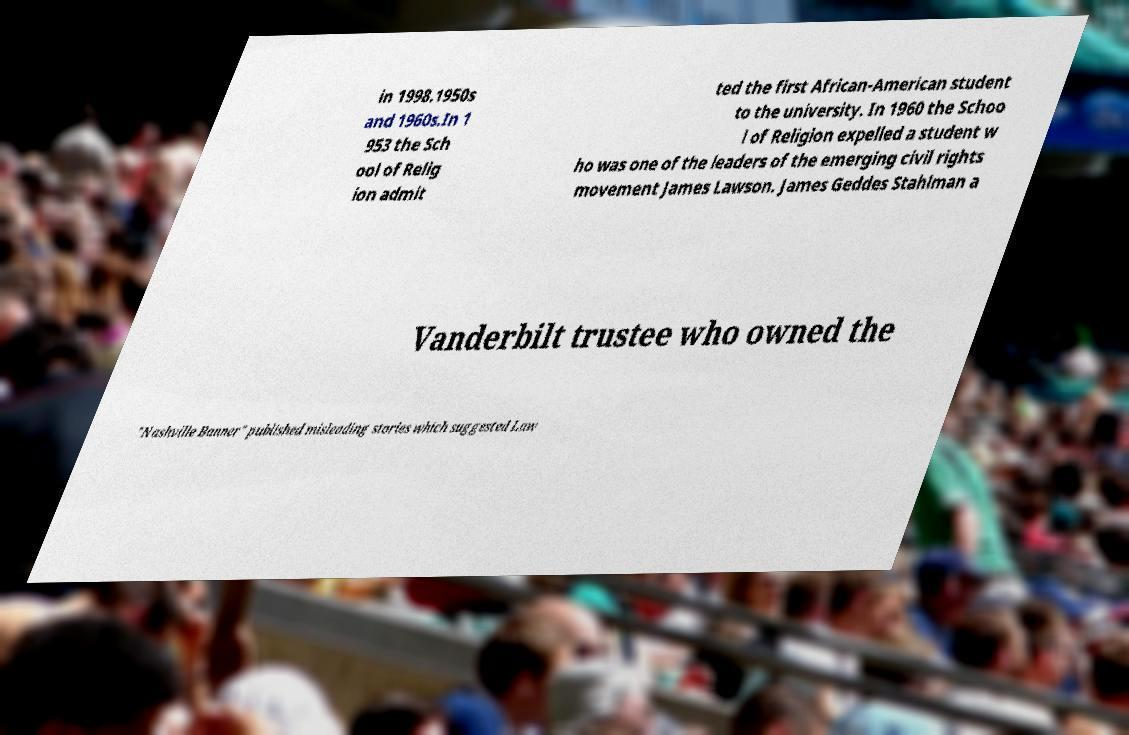Can you read and provide the text displayed in the image?This photo seems to have some interesting text. Can you extract and type it out for me? in 1998.1950s and 1960s.In 1 953 the Sch ool of Relig ion admit ted the first African-American student to the university. In 1960 the Schoo l of Religion expelled a student w ho was one of the leaders of the emerging civil rights movement James Lawson. James Geddes Stahlman a Vanderbilt trustee who owned the "Nashville Banner" published misleading stories which suggested Law 